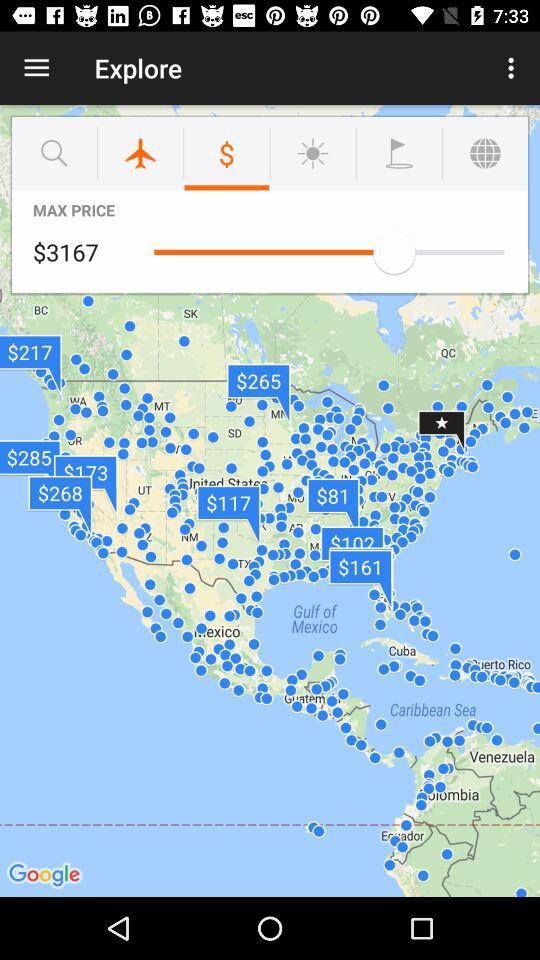What is the selected maximum price? The selected maximum price is $3167. 